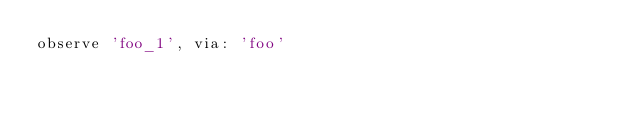<code> <loc_0><loc_0><loc_500><loc_500><_Ruby_>observe 'foo_1', via: 'foo'
</code> 